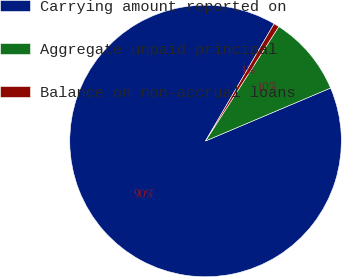Convert chart to OTSL. <chart><loc_0><loc_0><loc_500><loc_500><pie_chart><fcel>Carrying amount reported on<fcel>Aggregate unpaid principal<fcel>Balance on non-accrual loans<nl><fcel>89.8%<fcel>9.56%<fcel>0.64%<nl></chart> 